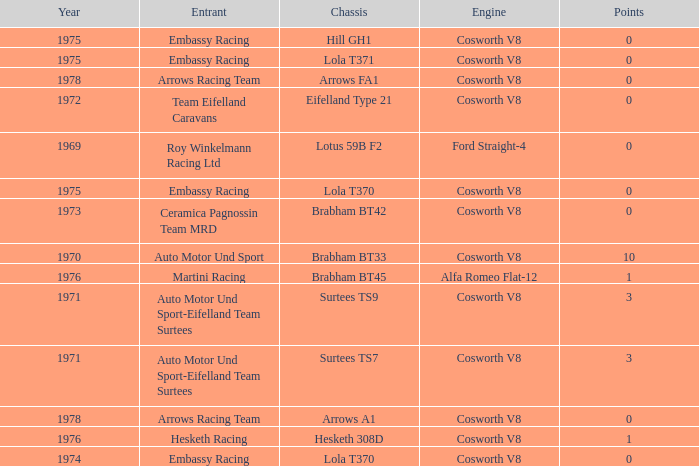Give me the full table as a dictionary. {'header': ['Year', 'Entrant', 'Chassis', 'Engine', 'Points'], 'rows': [['1975', 'Embassy Racing', 'Hill GH1', 'Cosworth V8', '0'], ['1975', 'Embassy Racing', 'Lola T371', 'Cosworth V8', '0'], ['1978', 'Arrows Racing Team', 'Arrows FA1', 'Cosworth V8', '0'], ['1972', 'Team Eifelland Caravans', 'Eifelland Type 21', 'Cosworth V8', '0'], ['1969', 'Roy Winkelmann Racing Ltd', 'Lotus 59B F2', 'Ford Straight-4', '0'], ['1975', 'Embassy Racing', 'Lola T370', 'Cosworth V8', '0'], ['1973', 'Ceramica Pagnossin Team MRD', 'Brabham BT42', 'Cosworth V8', '0'], ['1970', 'Auto Motor Und Sport', 'Brabham BT33', 'Cosworth V8', '10'], ['1976', 'Martini Racing', 'Brabham BT45', 'Alfa Romeo Flat-12', '1'], ['1971', 'Auto Motor Und Sport-Eifelland Team Surtees', 'Surtees TS9', 'Cosworth V8', '3'], ['1971', 'Auto Motor Und Sport-Eifelland Team Surtees', 'Surtees TS7', 'Cosworth V8', '3'], ['1978', 'Arrows Racing Team', 'Arrows A1', 'Cosworth V8', '0'], ['1976', 'Hesketh Racing', 'Hesketh 308D', 'Cosworth V8', '1'], ['1974', 'Embassy Racing', 'Lola T370', 'Cosworth V8', '0']]} Who was the entrant in 1971? Auto Motor Und Sport-Eifelland Team Surtees, Auto Motor Und Sport-Eifelland Team Surtees. 